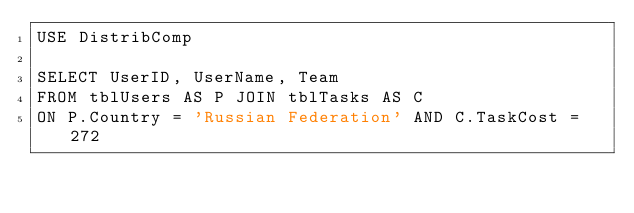Convert code to text. <code><loc_0><loc_0><loc_500><loc_500><_SQL_>USE DistribComp

SELECT UserID, UserName, Team
FROM tblUsers AS P JOIN tblTasks AS C
ON P.Country = 'Russian Federation' AND C.TaskCost = 272</code> 